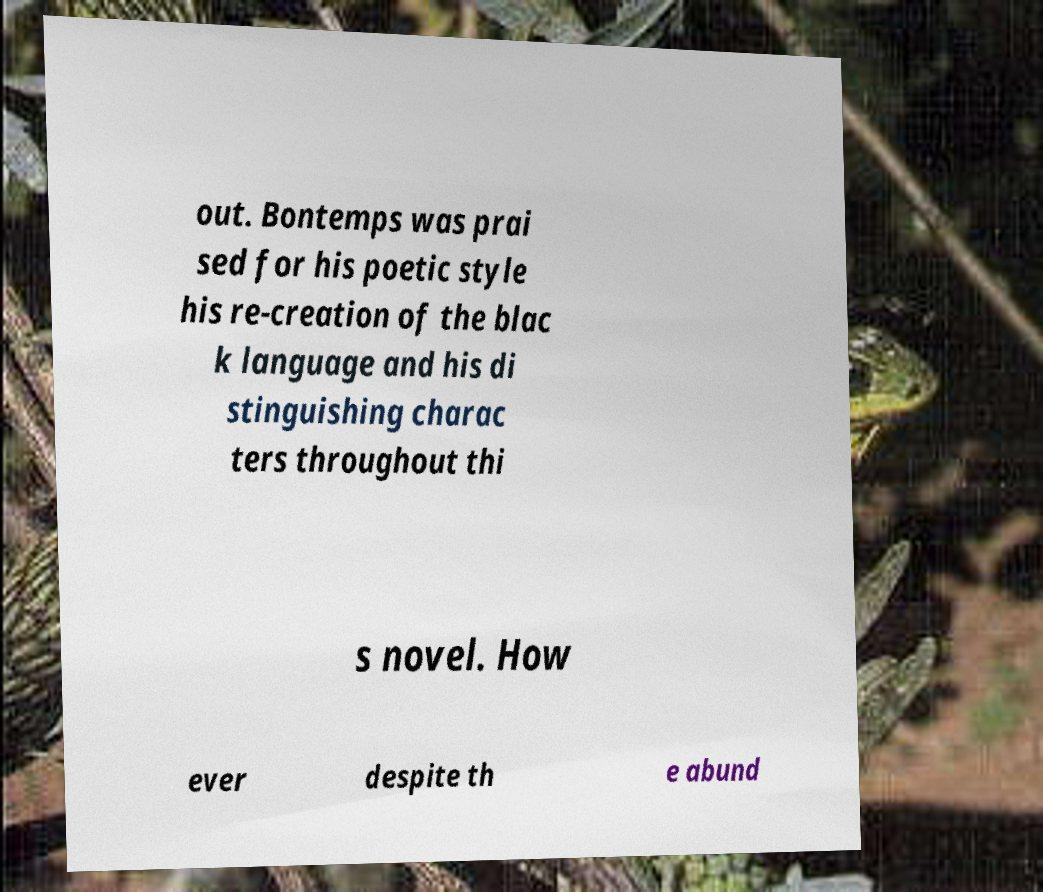What messages or text are displayed in this image? I need them in a readable, typed format. out. Bontemps was prai sed for his poetic style his re-creation of the blac k language and his di stinguishing charac ters throughout thi s novel. How ever despite th e abund 